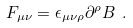Convert formula to latex. <formula><loc_0><loc_0><loc_500><loc_500>F _ { \mu \nu } = \epsilon _ { \mu \nu \rho } \partial ^ { \rho } B \ .</formula> 